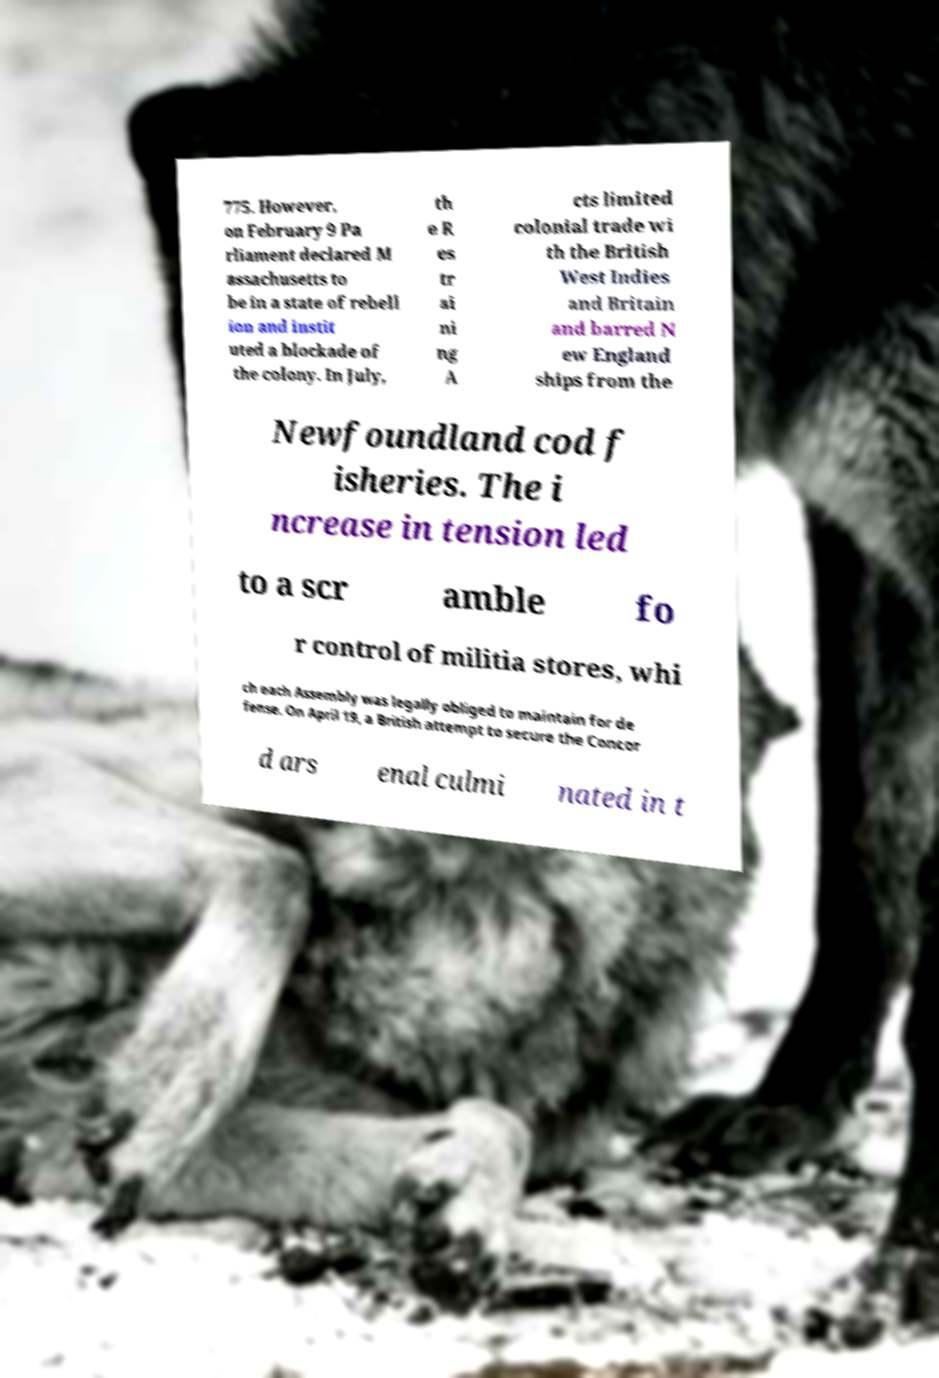Can you accurately transcribe the text from the provided image for me? 775. However, on February 9 Pa rliament declared M assachusetts to be in a state of rebell ion and instit uted a blockade of the colony. In July, th e R es tr ai ni ng A cts limited colonial trade wi th the British West Indies and Britain and barred N ew England ships from the Newfoundland cod f isheries. The i ncrease in tension led to a scr amble fo r control of militia stores, whi ch each Assembly was legally obliged to maintain for de fense. On April 19, a British attempt to secure the Concor d ars enal culmi nated in t 